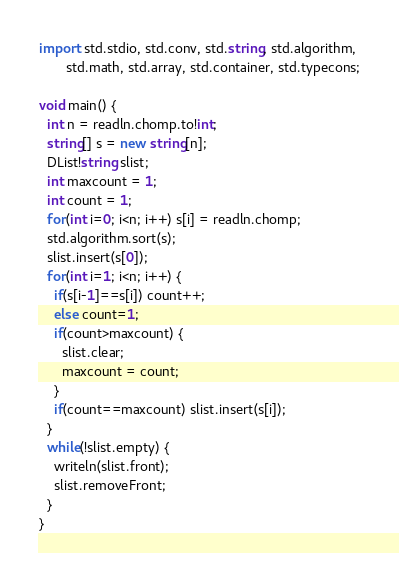<code> <loc_0><loc_0><loc_500><loc_500><_D_>import std.stdio, std.conv, std.string, std.algorithm,
       std.math, std.array, std.container, std.typecons;

void main() {
  int n = readln.chomp.to!int;
  string[] s = new string[n];
  DList!string slist;
  int maxcount = 1;
  int count = 1;
  for(int i=0; i<n; i++) s[i] = readln.chomp;
  std.algorithm.sort(s);
  slist.insert(s[0]);
  for(int i=1; i<n; i++) {
    if(s[i-1]==s[i]) count++;
    else count=1;
    if(count>maxcount) {
      slist.clear;
      maxcount = count;
    }
    if(count==maxcount) slist.insert(s[i]);
  }
  while(!slist.empty) {
    writeln(slist.front);
    slist.removeFront;
  }
}

</code> 